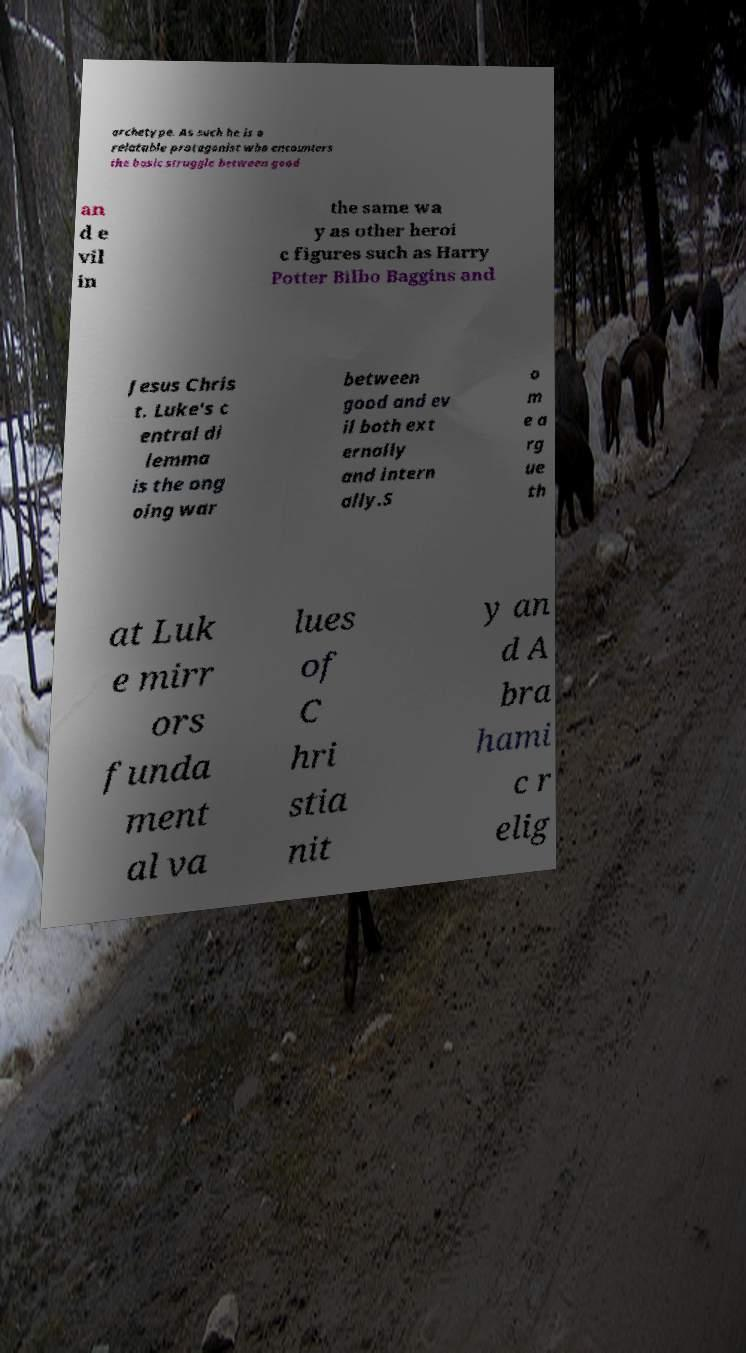Could you extract and type out the text from this image? archetype. As such he is a relatable protagonist who encounters the basic struggle between good an d e vil in the same wa y as other heroi c figures such as Harry Potter Bilbo Baggins and Jesus Chris t. Luke's c entral di lemma is the ong oing war between good and ev il both ext ernally and intern ally.S o m e a rg ue th at Luk e mirr ors funda ment al va lues of C hri stia nit y an d A bra hami c r elig 